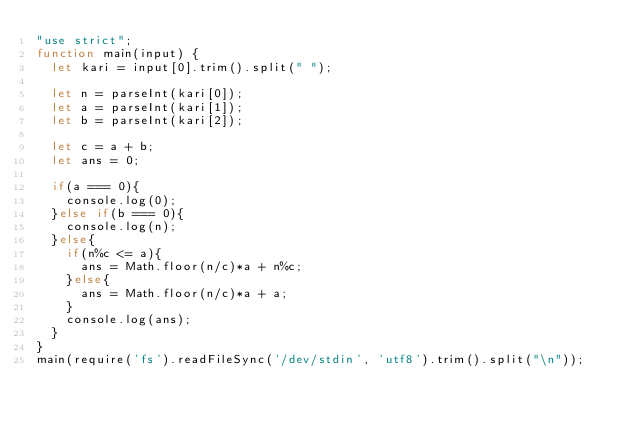<code> <loc_0><loc_0><loc_500><loc_500><_JavaScript_>"use strict";
function main(input) {
  let kari = input[0].trim().split(" ");
 
  let n = parseInt(kari[0]);
  let a = parseInt(kari[1]);
  let b = parseInt(kari[2]);
 
  let c = a + b;
  let ans = 0;

  if(a === 0){
    console.log(0);
  }else if(b === 0){
    console.log(n);
  }else{
    if(n%c <= a){
      ans = Math.floor(n/c)*a + n%c;
    }else{
      ans = Math.floor(n/c)*a + a;
    }
    console.log(ans);
  }
}
main(require('fs').readFileSync('/dev/stdin', 'utf8').trim().split("\n"));</code> 